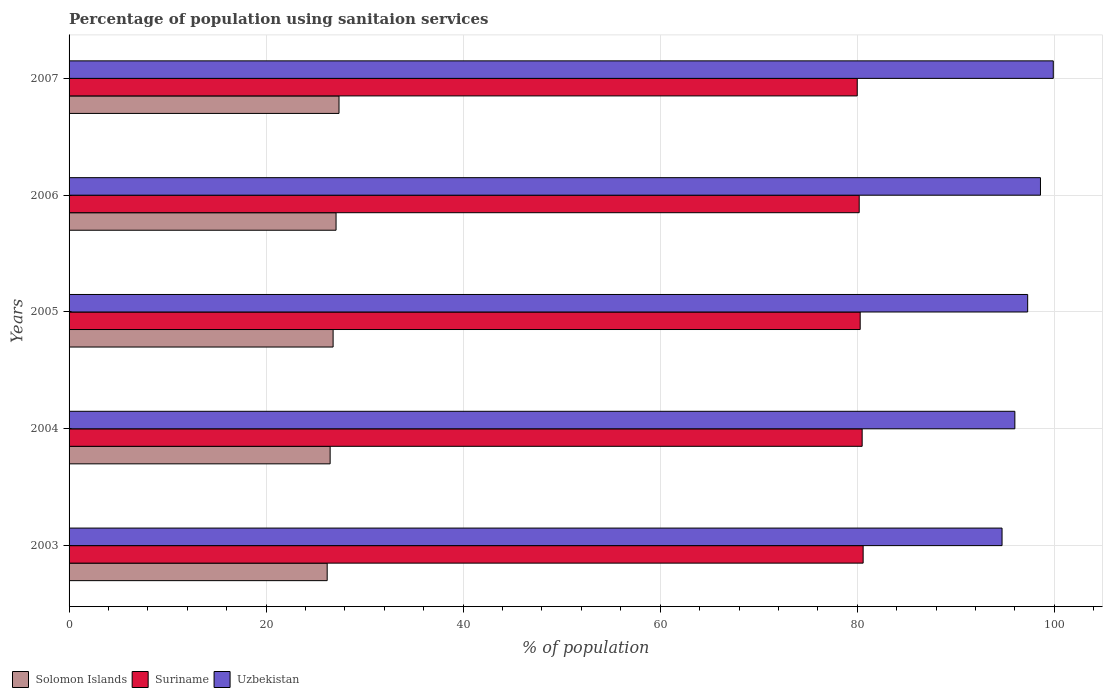How many bars are there on the 1st tick from the top?
Give a very brief answer. 3. How many bars are there on the 5th tick from the bottom?
Provide a succinct answer. 3. What is the label of the 1st group of bars from the top?
Provide a short and direct response. 2007. What is the percentage of population using sanitaion services in Uzbekistan in 2007?
Make the answer very short. 99.9. Across all years, what is the maximum percentage of population using sanitaion services in Solomon Islands?
Make the answer very short. 27.4. Across all years, what is the minimum percentage of population using sanitaion services in Uzbekistan?
Your response must be concise. 94.7. In which year was the percentage of population using sanitaion services in Solomon Islands minimum?
Your response must be concise. 2003. What is the total percentage of population using sanitaion services in Uzbekistan in the graph?
Your answer should be very brief. 486.5. What is the difference between the percentage of population using sanitaion services in Suriname in 2003 and that in 2006?
Your response must be concise. 0.4. What is the difference between the percentage of population using sanitaion services in Uzbekistan in 2005 and the percentage of population using sanitaion services in Solomon Islands in 2007?
Your answer should be very brief. 69.9. What is the average percentage of population using sanitaion services in Uzbekistan per year?
Offer a very short reply. 97.3. In the year 2003, what is the difference between the percentage of population using sanitaion services in Suriname and percentage of population using sanitaion services in Uzbekistan?
Ensure brevity in your answer.  -14.1. What is the ratio of the percentage of population using sanitaion services in Suriname in 2003 to that in 2005?
Make the answer very short. 1. Is the difference between the percentage of population using sanitaion services in Suriname in 2003 and 2006 greater than the difference between the percentage of population using sanitaion services in Uzbekistan in 2003 and 2006?
Give a very brief answer. Yes. What is the difference between the highest and the second highest percentage of population using sanitaion services in Solomon Islands?
Offer a very short reply. 0.3. What is the difference between the highest and the lowest percentage of population using sanitaion services in Uzbekistan?
Provide a succinct answer. 5.2. Is the sum of the percentage of population using sanitaion services in Solomon Islands in 2005 and 2007 greater than the maximum percentage of population using sanitaion services in Suriname across all years?
Provide a short and direct response. No. What does the 3rd bar from the top in 2004 represents?
Your answer should be very brief. Solomon Islands. What does the 2nd bar from the bottom in 2003 represents?
Provide a short and direct response. Suriname. How many bars are there?
Provide a short and direct response. 15. How many years are there in the graph?
Ensure brevity in your answer.  5. Are the values on the major ticks of X-axis written in scientific E-notation?
Give a very brief answer. No. Does the graph contain any zero values?
Provide a succinct answer. No. How many legend labels are there?
Your answer should be very brief. 3. How are the legend labels stacked?
Ensure brevity in your answer.  Horizontal. What is the title of the graph?
Offer a terse response. Percentage of population using sanitaion services. Does "Moldova" appear as one of the legend labels in the graph?
Give a very brief answer. No. What is the label or title of the X-axis?
Your answer should be compact. % of population. What is the % of population in Solomon Islands in 2003?
Your answer should be compact. 26.2. What is the % of population of Suriname in 2003?
Your answer should be compact. 80.6. What is the % of population of Uzbekistan in 2003?
Your answer should be very brief. 94.7. What is the % of population in Solomon Islands in 2004?
Give a very brief answer. 26.5. What is the % of population of Suriname in 2004?
Provide a succinct answer. 80.5. What is the % of population in Uzbekistan in 2004?
Your response must be concise. 96. What is the % of population of Solomon Islands in 2005?
Make the answer very short. 26.8. What is the % of population of Suriname in 2005?
Provide a succinct answer. 80.3. What is the % of population of Uzbekistan in 2005?
Your answer should be very brief. 97.3. What is the % of population in Solomon Islands in 2006?
Make the answer very short. 27.1. What is the % of population in Suriname in 2006?
Give a very brief answer. 80.2. What is the % of population of Uzbekistan in 2006?
Your answer should be compact. 98.6. What is the % of population of Solomon Islands in 2007?
Provide a short and direct response. 27.4. What is the % of population in Suriname in 2007?
Your answer should be very brief. 80. What is the % of population in Uzbekistan in 2007?
Keep it short and to the point. 99.9. Across all years, what is the maximum % of population of Solomon Islands?
Keep it short and to the point. 27.4. Across all years, what is the maximum % of population in Suriname?
Offer a very short reply. 80.6. Across all years, what is the maximum % of population of Uzbekistan?
Ensure brevity in your answer.  99.9. Across all years, what is the minimum % of population in Solomon Islands?
Make the answer very short. 26.2. Across all years, what is the minimum % of population of Uzbekistan?
Give a very brief answer. 94.7. What is the total % of population of Solomon Islands in the graph?
Ensure brevity in your answer.  134. What is the total % of population in Suriname in the graph?
Your answer should be very brief. 401.6. What is the total % of population in Uzbekistan in the graph?
Your response must be concise. 486.5. What is the difference between the % of population of Solomon Islands in 2003 and that in 2004?
Ensure brevity in your answer.  -0.3. What is the difference between the % of population in Suriname in 2003 and that in 2004?
Provide a short and direct response. 0.1. What is the difference between the % of population in Uzbekistan in 2003 and that in 2004?
Your answer should be very brief. -1.3. What is the difference between the % of population in Solomon Islands in 2003 and that in 2005?
Your response must be concise. -0.6. What is the difference between the % of population of Suriname in 2003 and that in 2005?
Your answer should be very brief. 0.3. What is the difference between the % of population in Uzbekistan in 2003 and that in 2005?
Your response must be concise. -2.6. What is the difference between the % of population of Solomon Islands in 2003 and that in 2006?
Your answer should be compact. -0.9. What is the difference between the % of population of Suriname in 2003 and that in 2006?
Your response must be concise. 0.4. What is the difference between the % of population of Solomon Islands in 2003 and that in 2007?
Ensure brevity in your answer.  -1.2. What is the difference between the % of population of Suriname in 2003 and that in 2007?
Your answer should be compact. 0.6. What is the difference between the % of population in Solomon Islands in 2004 and that in 2005?
Keep it short and to the point. -0.3. What is the difference between the % of population in Suriname in 2004 and that in 2005?
Provide a succinct answer. 0.2. What is the difference between the % of population in Uzbekistan in 2004 and that in 2005?
Offer a terse response. -1.3. What is the difference between the % of population of Suriname in 2004 and that in 2006?
Offer a terse response. 0.3. What is the difference between the % of population in Uzbekistan in 2004 and that in 2006?
Offer a very short reply. -2.6. What is the difference between the % of population in Suriname in 2004 and that in 2007?
Provide a short and direct response. 0.5. What is the difference between the % of population of Uzbekistan in 2004 and that in 2007?
Make the answer very short. -3.9. What is the difference between the % of population in Solomon Islands in 2005 and that in 2006?
Provide a succinct answer. -0.3. What is the difference between the % of population of Uzbekistan in 2005 and that in 2006?
Keep it short and to the point. -1.3. What is the difference between the % of population in Solomon Islands in 2005 and that in 2007?
Your answer should be compact. -0.6. What is the difference between the % of population in Solomon Islands in 2006 and that in 2007?
Keep it short and to the point. -0.3. What is the difference between the % of population of Suriname in 2006 and that in 2007?
Offer a very short reply. 0.2. What is the difference between the % of population in Uzbekistan in 2006 and that in 2007?
Provide a short and direct response. -1.3. What is the difference between the % of population in Solomon Islands in 2003 and the % of population in Suriname in 2004?
Your response must be concise. -54.3. What is the difference between the % of population in Solomon Islands in 2003 and the % of population in Uzbekistan in 2004?
Your answer should be very brief. -69.8. What is the difference between the % of population in Suriname in 2003 and the % of population in Uzbekistan in 2004?
Offer a very short reply. -15.4. What is the difference between the % of population of Solomon Islands in 2003 and the % of population of Suriname in 2005?
Give a very brief answer. -54.1. What is the difference between the % of population in Solomon Islands in 2003 and the % of population in Uzbekistan in 2005?
Offer a terse response. -71.1. What is the difference between the % of population of Suriname in 2003 and the % of population of Uzbekistan in 2005?
Your answer should be very brief. -16.7. What is the difference between the % of population in Solomon Islands in 2003 and the % of population in Suriname in 2006?
Your response must be concise. -54. What is the difference between the % of population in Solomon Islands in 2003 and the % of population in Uzbekistan in 2006?
Give a very brief answer. -72.4. What is the difference between the % of population of Suriname in 2003 and the % of population of Uzbekistan in 2006?
Your answer should be very brief. -18. What is the difference between the % of population of Solomon Islands in 2003 and the % of population of Suriname in 2007?
Make the answer very short. -53.8. What is the difference between the % of population in Solomon Islands in 2003 and the % of population in Uzbekistan in 2007?
Your answer should be very brief. -73.7. What is the difference between the % of population of Suriname in 2003 and the % of population of Uzbekistan in 2007?
Your answer should be very brief. -19.3. What is the difference between the % of population of Solomon Islands in 2004 and the % of population of Suriname in 2005?
Give a very brief answer. -53.8. What is the difference between the % of population in Solomon Islands in 2004 and the % of population in Uzbekistan in 2005?
Your answer should be very brief. -70.8. What is the difference between the % of population of Suriname in 2004 and the % of population of Uzbekistan in 2005?
Give a very brief answer. -16.8. What is the difference between the % of population in Solomon Islands in 2004 and the % of population in Suriname in 2006?
Give a very brief answer. -53.7. What is the difference between the % of population in Solomon Islands in 2004 and the % of population in Uzbekistan in 2006?
Your answer should be very brief. -72.1. What is the difference between the % of population in Suriname in 2004 and the % of population in Uzbekistan in 2006?
Make the answer very short. -18.1. What is the difference between the % of population of Solomon Islands in 2004 and the % of population of Suriname in 2007?
Provide a succinct answer. -53.5. What is the difference between the % of population of Solomon Islands in 2004 and the % of population of Uzbekistan in 2007?
Ensure brevity in your answer.  -73.4. What is the difference between the % of population in Suriname in 2004 and the % of population in Uzbekistan in 2007?
Keep it short and to the point. -19.4. What is the difference between the % of population of Solomon Islands in 2005 and the % of population of Suriname in 2006?
Ensure brevity in your answer.  -53.4. What is the difference between the % of population of Solomon Islands in 2005 and the % of population of Uzbekistan in 2006?
Offer a terse response. -71.8. What is the difference between the % of population in Suriname in 2005 and the % of population in Uzbekistan in 2006?
Offer a very short reply. -18.3. What is the difference between the % of population of Solomon Islands in 2005 and the % of population of Suriname in 2007?
Keep it short and to the point. -53.2. What is the difference between the % of population in Solomon Islands in 2005 and the % of population in Uzbekistan in 2007?
Your answer should be compact. -73.1. What is the difference between the % of population in Suriname in 2005 and the % of population in Uzbekistan in 2007?
Provide a succinct answer. -19.6. What is the difference between the % of population of Solomon Islands in 2006 and the % of population of Suriname in 2007?
Provide a short and direct response. -52.9. What is the difference between the % of population in Solomon Islands in 2006 and the % of population in Uzbekistan in 2007?
Your response must be concise. -72.8. What is the difference between the % of population of Suriname in 2006 and the % of population of Uzbekistan in 2007?
Offer a very short reply. -19.7. What is the average % of population of Solomon Islands per year?
Your response must be concise. 26.8. What is the average % of population of Suriname per year?
Ensure brevity in your answer.  80.32. What is the average % of population of Uzbekistan per year?
Offer a terse response. 97.3. In the year 2003, what is the difference between the % of population of Solomon Islands and % of population of Suriname?
Provide a succinct answer. -54.4. In the year 2003, what is the difference between the % of population in Solomon Islands and % of population in Uzbekistan?
Ensure brevity in your answer.  -68.5. In the year 2003, what is the difference between the % of population of Suriname and % of population of Uzbekistan?
Offer a terse response. -14.1. In the year 2004, what is the difference between the % of population of Solomon Islands and % of population of Suriname?
Provide a short and direct response. -54. In the year 2004, what is the difference between the % of population of Solomon Islands and % of population of Uzbekistan?
Keep it short and to the point. -69.5. In the year 2004, what is the difference between the % of population of Suriname and % of population of Uzbekistan?
Your response must be concise. -15.5. In the year 2005, what is the difference between the % of population in Solomon Islands and % of population in Suriname?
Provide a succinct answer. -53.5. In the year 2005, what is the difference between the % of population of Solomon Islands and % of population of Uzbekistan?
Provide a succinct answer. -70.5. In the year 2006, what is the difference between the % of population in Solomon Islands and % of population in Suriname?
Offer a very short reply. -53.1. In the year 2006, what is the difference between the % of population of Solomon Islands and % of population of Uzbekistan?
Your response must be concise. -71.5. In the year 2006, what is the difference between the % of population in Suriname and % of population in Uzbekistan?
Provide a succinct answer. -18.4. In the year 2007, what is the difference between the % of population of Solomon Islands and % of population of Suriname?
Offer a terse response. -52.6. In the year 2007, what is the difference between the % of population of Solomon Islands and % of population of Uzbekistan?
Your answer should be compact. -72.5. In the year 2007, what is the difference between the % of population of Suriname and % of population of Uzbekistan?
Provide a short and direct response. -19.9. What is the ratio of the % of population of Solomon Islands in 2003 to that in 2004?
Offer a terse response. 0.99. What is the ratio of the % of population in Uzbekistan in 2003 to that in 2004?
Your answer should be very brief. 0.99. What is the ratio of the % of population of Solomon Islands in 2003 to that in 2005?
Make the answer very short. 0.98. What is the ratio of the % of population in Suriname in 2003 to that in 2005?
Provide a short and direct response. 1. What is the ratio of the % of population in Uzbekistan in 2003 to that in 2005?
Your answer should be very brief. 0.97. What is the ratio of the % of population of Solomon Islands in 2003 to that in 2006?
Offer a terse response. 0.97. What is the ratio of the % of population in Suriname in 2003 to that in 2006?
Give a very brief answer. 1. What is the ratio of the % of population of Uzbekistan in 2003 to that in 2006?
Provide a succinct answer. 0.96. What is the ratio of the % of population in Solomon Islands in 2003 to that in 2007?
Make the answer very short. 0.96. What is the ratio of the % of population of Suriname in 2003 to that in 2007?
Offer a terse response. 1.01. What is the ratio of the % of population of Uzbekistan in 2003 to that in 2007?
Provide a short and direct response. 0.95. What is the ratio of the % of population of Uzbekistan in 2004 to that in 2005?
Your response must be concise. 0.99. What is the ratio of the % of population of Solomon Islands in 2004 to that in 2006?
Provide a succinct answer. 0.98. What is the ratio of the % of population in Uzbekistan in 2004 to that in 2006?
Keep it short and to the point. 0.97. What is the ratio of the % of population in Solomon Islands in 2004 to that in 2007?
Provide a short and direct response. 0.97. What is the ratio of the % of population in Suriname in 2004 to that in 2007?
Give a very brief answer. 1.01. What is the ratio of the % of population in Solomon Islands in 2005 to that in 2006?
Your answer should be very brief. 0.99. What is the ratio of the % of population of Solomon Islands in 2005 to that in 2007?
Make the answer very short. 0.98. What is the ratio of the % of population in Suriname in 2005 to that in 2007?
Keep it short and to the point. 1. What is the ratio of the % of population of Solomon Islands in 2006 to that in 2007?
Give a very brief answer. 0.99. What is the ratio of the % of population in Uzbekistan in 2006 to that in 2007?
Give a very brief answer. 0.99. What is the difference between the highest and the second highest % of population of Suriname?
Give a very brief answer. 0.1. What is the difference between the highest and the second highest % of population of Uzbekistan?
Your answer should be compact. 1.3. What is the difference between the highest and the lowest % of population in Solomon Islands?
Your answer should be compact. 1.2. 